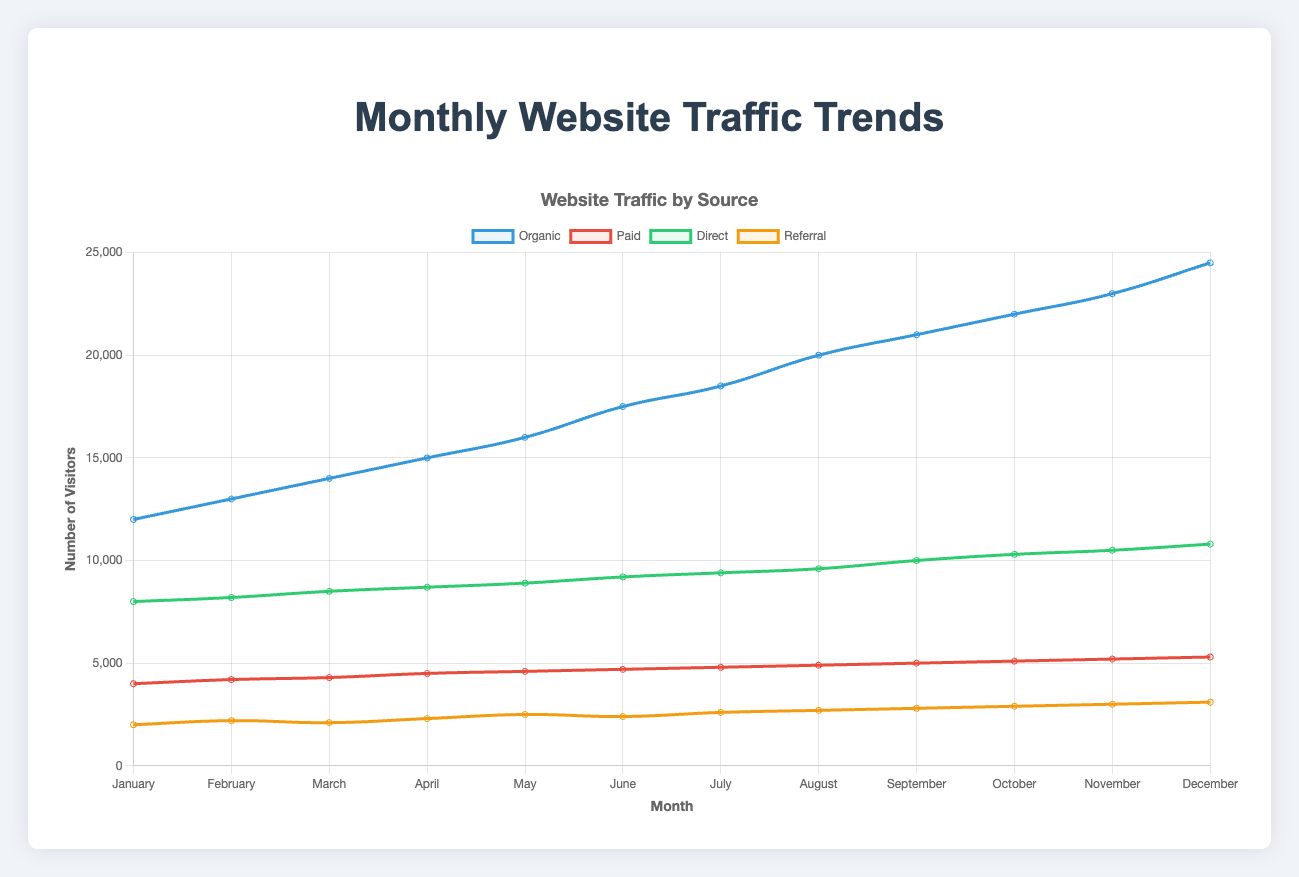What's the highest number of monthly visitors from any source? By examining the peaks of each line in the chart, the highest number of monthly visitors from any source is from Organic traffic in December, which is 24,500 visitors
Answer: 24,500 Which month experienced the highest total website traffic across all sources? Sum the traffic from all sources for each month and compare them. December has the highest total traffic: (24,500 + 5,300 + 10,800 + 3,100) = 43,700 visitors
Answer: December What is the average monthly traffic from Organic sources? Add up the Organic traffic for each month: (12,000 + 13,000 + 14,000 + 15,000 + 16,000 + 17,500 + 18,500 + 20,000 + 21,000 + 22,000 + 23,000 + 24,500) = 216,500, then divide by the number of months (12) to get the average: 216,500 / 12 = 18,041.67
Answer: 18,041.67 How does the Direct traffic in June compare to the Paid traffic in June? In June, Direct traffic is 9,200 visitors and Paid traffic is 4,700 visitors. Direct traffic is higher than Paid traffic by (9,200 - 4,700) = 4,500 visitors
Answer: Direct traffic is higher by 4,500 visitors Which traffic source had the smallest increase from January to December? Calculate the difference for each source between December and January. 
Organic: 24,500 - 12,000 = 12,500
Paid: 5,300 - 4,000 = 1,300
Direct: 10,800 - 8,000 = 2,800
Referral: 3,100 - 2,000 = 1,100
The source with the smallest increase is Referral traffic with an increase of 1,100 visitors
Answer: Referral traffic What is the monthly trend for Referral traffic? By examining the Referral traffic line, there is a general increasing trend from 2,000 visitors in January to 3,100 visitors in December, with small fluctuations around 2,100 to 2,500 in the middle months
Answer: Increasing How does the trend of Organic traffic compare to the trend of Paid traffic? Organic traffic shows a steady upward trend from January (12,000) to December (24,500). Paid traffic also shows an upward trend, but the increase is less pronounced, from January (4,000) to December (5,300)
Answer: Organic traffic increases more than Paid traffic In which months did Referral traffic surpass 2,500 visitors? Referral traffic values: 2,500 in May, 2,600 in July, 2,700 in August, 2,800 in September, 2,900 in October, 3,000 in November, and 3,100 in December. Therefore, May to December all surpass 2,500 visitors
Answer: May to December Which traffic source consistently shows the highest numbers throughout the year? By visually comparing the lines, Organic traffic consistently shows the highest numbers every month, starting at 12,000 in January and ending at 24,500 in December
Answer: Organic traffic What is the difference in traffic between the peak month for Paid traffic and the peak month for Direct traffic? Paid traffic peaks in December with 5,300 visitors, while Direct traffic peaks in December with 10,800 visitors. The difference is (10,800 - 5,300) = 5,500 visitors
Answer: 5,500 